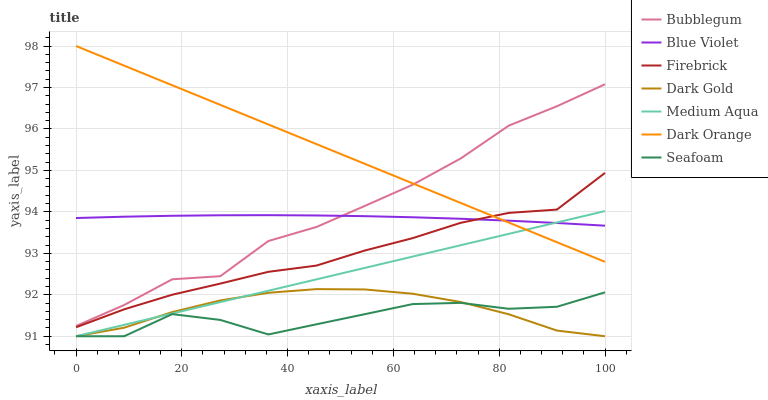Does Seafoam have the minimum area under the curve?
Answer yes or no. Yes. Does Dark Orange have the maximum area under the curve?
Answer yes or no. Yes. Does Dark Gold have the minimum area under the curve?
Answer yes or no. No. Does Dark Gold have the maximum area under the curve?
Answer yes or no. No. Is Dark Orange the smoothest?
Answer yes or no. Yes. Is Seafoam the roughest?
Answer yes or no. Yes. Is Dark Gold the smoothest?
Answer yes or no. No. Is Dark Gold the roughest?
Answer yes or no. No. Does Dark Gold have the lowest value?
Answer yes or no. Yes. Does Firebrick have the lowest value?
Answer yes or no. No. Does Dark Orange have the highest value?
Answer yes or no. Yes. Does Dark Gold have the highest value?
Answer yes or no. No. Is Medium Aqua less than Bubblegum?
Answer yes or no. Yes. Is Blue Violet greater than Seafoam?
Answer yes or no. Yes. Does Firebrick intersect Dark Orange?
Answer yes or no. Yes. Is Firebrick less than Dark Orange?
Answer yes or no. No. Is Firebrick greater than Dark Orange?
Answer yes or no. No. Does Medium Aqua intersect Bubblegum?
Answer yes or no. No. 